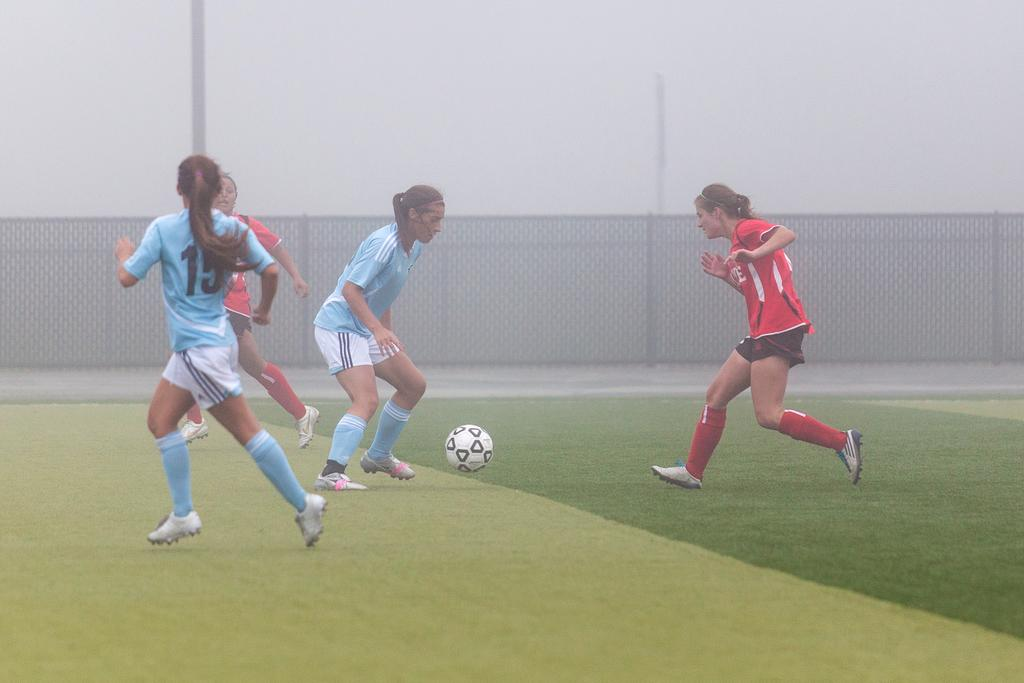<image>
Share a concise interpretation of the image provided. Player number 15 watches her teammate with the soccer ball. 